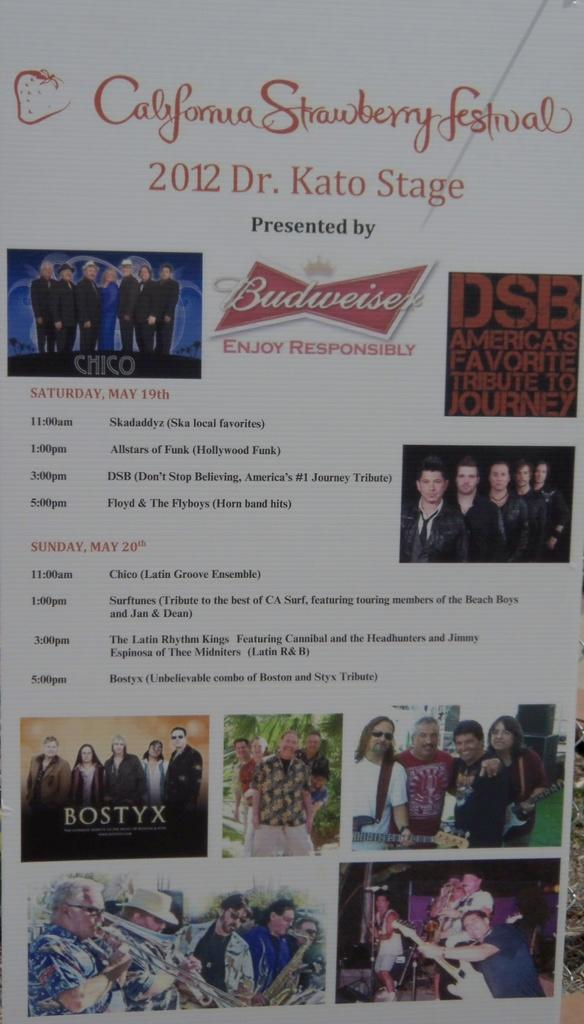<image>
Create a compact narrative representing the image presented. advertisement for the california strawberry festival with a log ofor budweiser on the middle. 